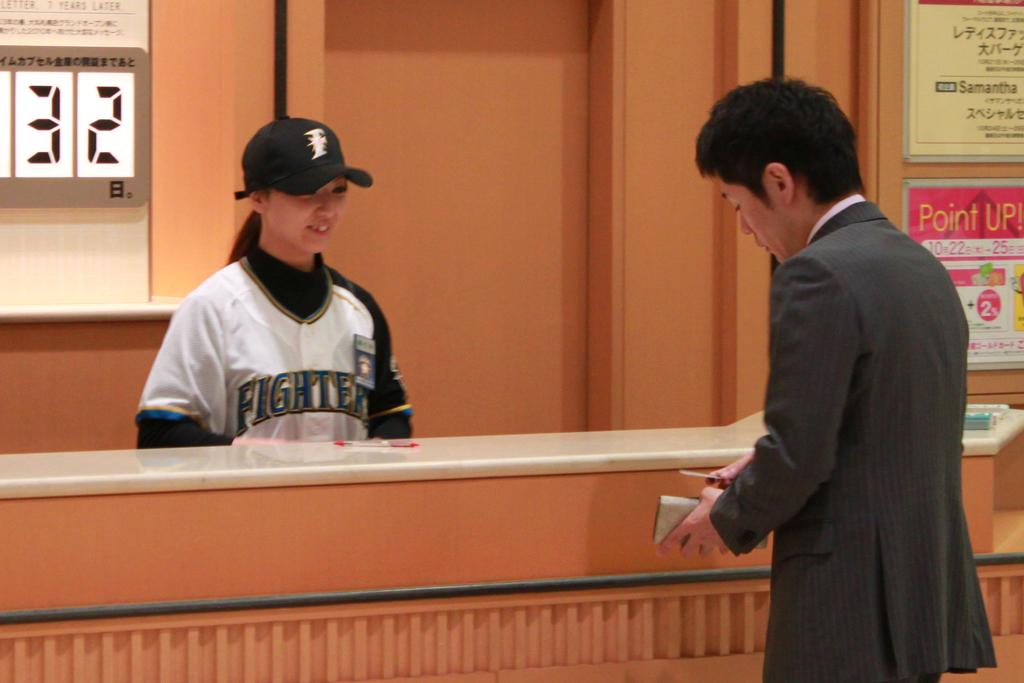<image>
Give a short and clear explanation of the subsequent image. A woman behind a counter wears a Fighter jersey. 